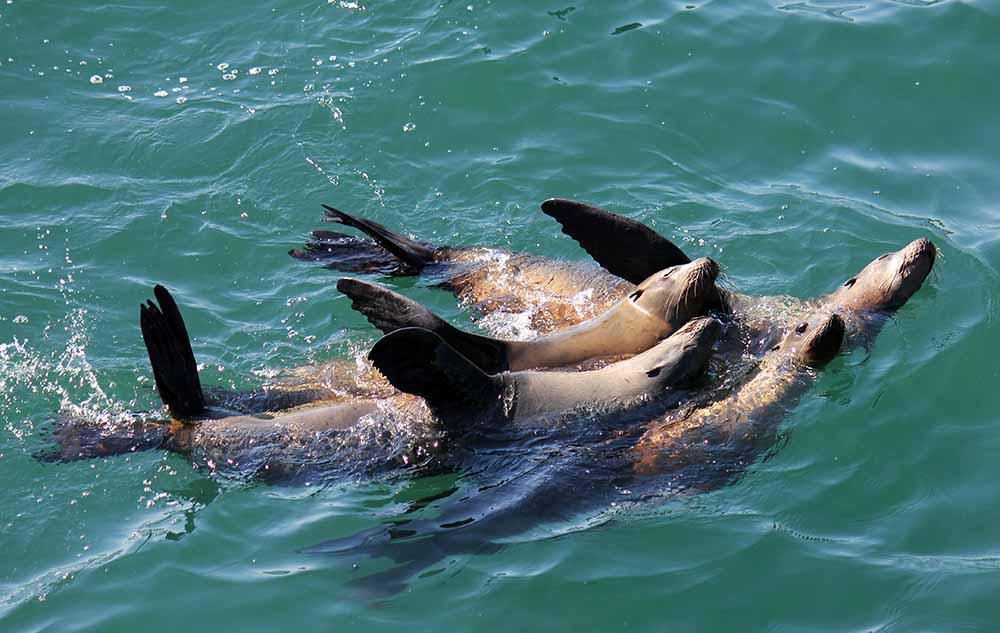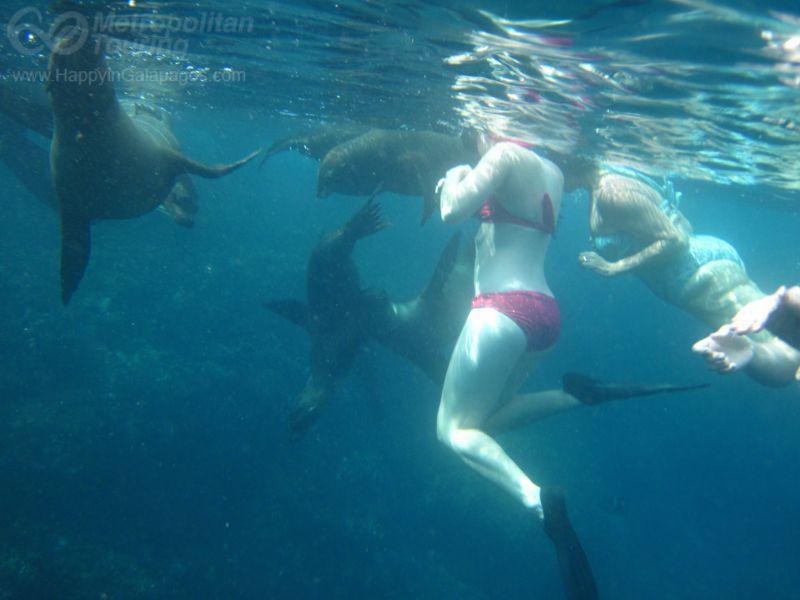The first image is the image on the left, the second image is the image on the right. Considering the images on both sides, is "The right image image contains exactly one seal." valid? Answer yes or no. No. The first image is the image on the left, the second image is the image on the right. Examine the images to the left and right. Is the description "There are more than ten sea lions in the images." accurate? Answer yes or no. No. 